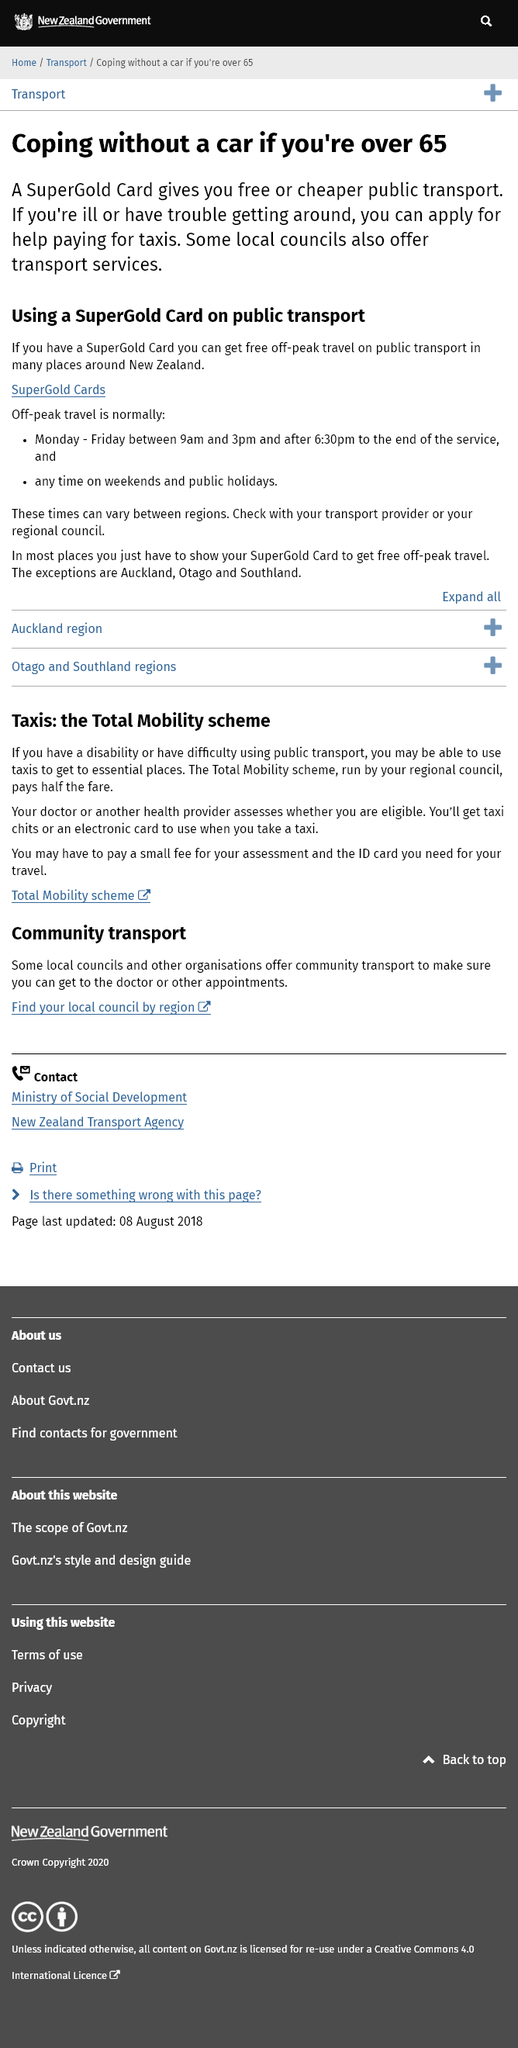Outline some significant characteristics in this image. In New Zealand, it is possible to obtain free or discounted public transportation during off-peak hours. I am available to travel from 9 am to 3 pm and after 6:30 pm on weekdays, and at any time on weekends and public holidays. It is possible to use a SuperGold card for public transportation. 